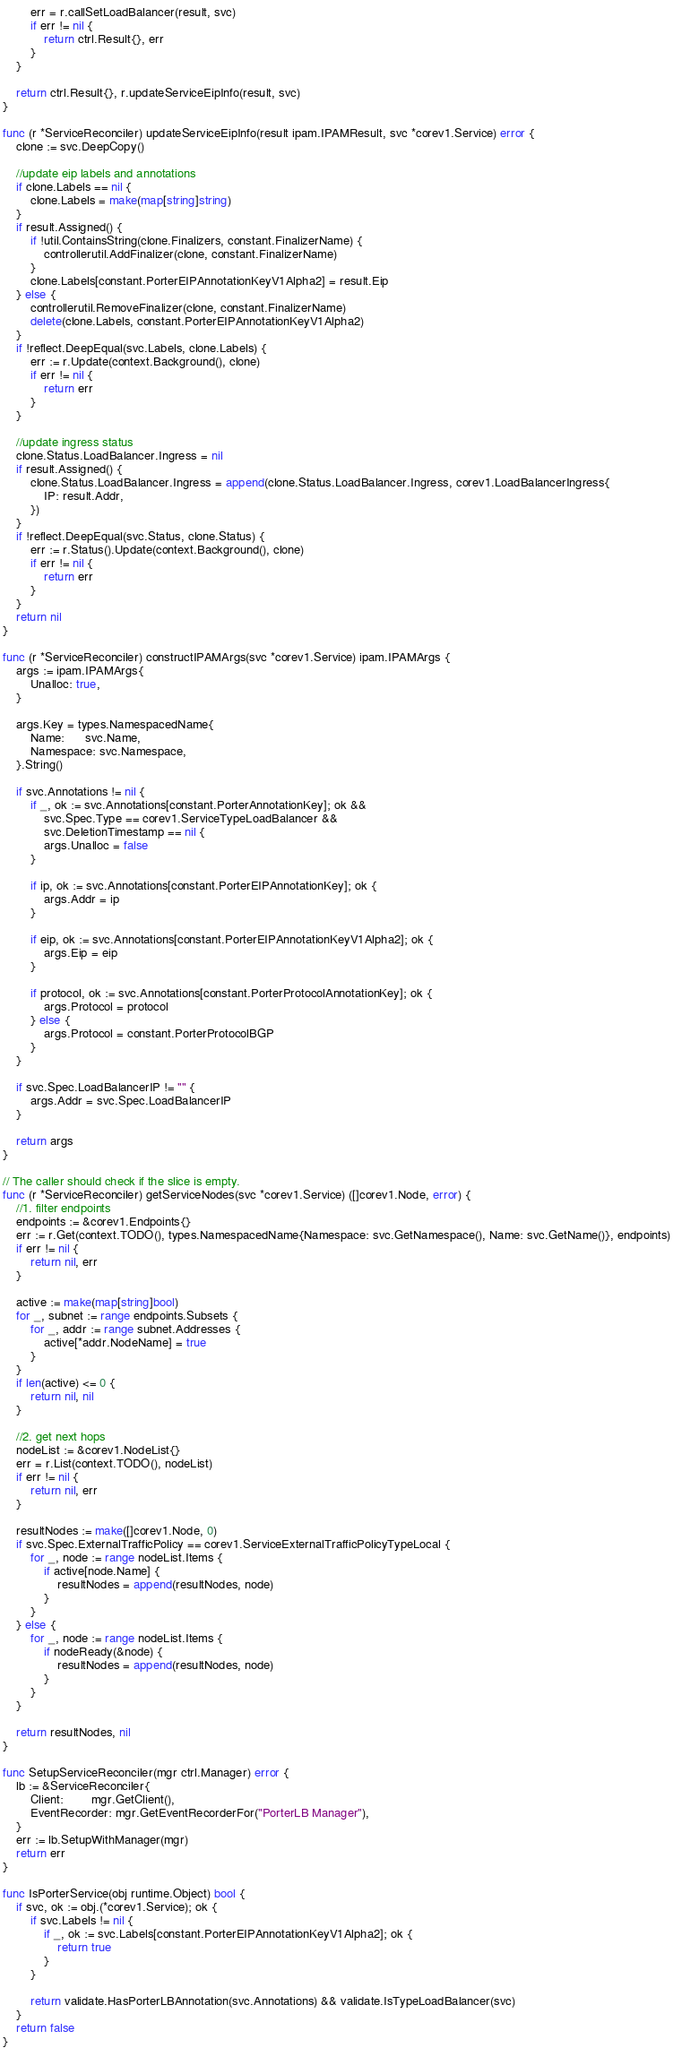<code> <loc_0><loc_0><loc_500><loc_500><_Go_>
		err = r.callSetLoadBalancer(result, svc)
		if err != nil {
			return ctrl.Result{}, err
		}
	}

	return ctrl.Result{}, r.updateServiceEipInfo(result, svc)
}

func (r *ServiceReconciler) updateServiceEipInfo(result ipam.IPAMResult, svc *corev1.Service) error {
	clone := svc.DeepCopy()

	//update eip labels and annotations
	if clone.Labels == nil {
		clone.Labels = make(map[string]string)
	}
	if result.Assigned() {
		if !util.ContainsString(clone.Finalizers, constant.FinalizerName) {
			controllerutil.AddFinalizer(clone, constant.FinalizerName)
		}
		clone.Labels[constant.PorterEIPAnnotationKeyV1Alpha2] = result.Eip
	} else {
		controllerutil.RemoveFinalizer(clone, constant.FinalizerName)
		delete(clone.Labels, constant.PorterEIPAnnotationKeyV1Alpha2)
	}
	if !reflect.DeepEqual(svc.Labels, clone.Labels) {
		err := r.Update(context.Background(), clone)
		if err != nil {
			return err
		}
	}

	//update ingress status
	clone.Status.LoadBalancer.Ingress = nil
	if result.Assigned() {
		clone.Status.LoadBalancer.Ingress = append(clone.Status.LoadBalancer.Ingress, corev1.LoadBalancerIngress{
			IP: result.Addr,
		})
	}
	if !reflect.DeepEqual(svc.Status, clone.Status) {
		err := r.Status().Update(context.Background(), clone)
		if err != nil {
			return err
		}
	}
	return nil
}

func (r *ServiceReconciler) constructIPAMArgs(svc *corev1.Service) ipam.IPAMArgs {
	args := ipam.IPAMArgs{
		Unalloc: true,
	}

	args.Key = types.NamespacedName{
		Name:      svc.Name,
		Namespace: svc.Namespace,
	}.String()

	if svc.Annotations != nil {
		if _, ok := svc.Annotations[constant.PorterAnnotationKey]; ok &&
			svc.Spec.Type == corev1.ServiceTypeLoadBalancer &&
			svc.DeletionTimestamp == nil {
			args.Unalloc = false
		}

		if ip, ok := svc.Annotations[constant.PorterEIPAnnotationKey]; ok {
			args.Addr = ip
		}

		if eip, ok := svc.Annotations[constant.PorterEIPAnnotationKeyV1Alpha2]; ok {
			args.Eip = eip
		}

		if protocol, ok := svc.Annotations[constant.PorterProtocolAnnotationKey]; ok {
			args.Protocol = protocol
		} else {
			args.Protocol = constant.PorterProtocolBGP
		}
	}

	if svc.Spec.LoadBalancerIP != "" {
		args.Addr = svc.Spec.LoadBalancerIP
	}

	return args
}

// The caller should check if the slice is empty.
func (r *ServiceReconciler) getServiceNodes(svc *corev1.Service) ([]corev1.Node, error) {
	//1. filter endpoints
	endpoints := &corev1.Endpoints{}
	err := r.Get(context.TODO(), types.NamespacedName{Namespace: svc.GetNamespace(), Name: svc.GetName()}, endpoints)
	if err != nil {
		return nil, err
	}

	active := make(map[string]bool)
	for _, subnet := range endpoints.Subsets {
		for _, addr := range subnet.Addresses {
			active[*addr.NodeName] = true
		}
	}
	if len(active) <= 0 {
		return nil, nil
	}

	//2. get next hops
	nodeList := &corev1.NodeList{}
	err = r.List(context.TODO(), nodeList)
	if err != nil {
		return nil, err
	}

	resultNodes := make([]corev1.Node, 0)
	if svc.Spec.ExternalTrafficPolicy == corev1.ServiceExternalTrafficPolicyTypeLocal {
		for _, node := range nodeList.Items {
			if active[node.Name] {
				resultNodes = append(resultNodes, node)
			}
		}
	} else {
		for _, node := range nodeList.Items {
			if nodeReady(&node) {
				resultNodes = append(resultNodes, node)
			}
		}
	}

	return resultNodes, nil
}

func SetupServiceReconciler(mgr ctrl.Manager) error {
	lb := &ServiceReconciler{
		Client:        mgr.GetClient(),
		EventRecorder: mgr.GetEventRecorderFor("PorterLB Manager"),
	}
	err := lb.SetupWithManager(mgr)
	return err
}

func IsPorterService(obj runtime.Object) bool {
	if svc, ok := obj.(*corev1.Service); ok {
		if svc.Labels != nil {
			if _, ok := svc.Labels[constant.PorterEIPAnnotationKeyV1Alpha2]; ok {
				return true
			}
		}

		return validate.HasPorterLBAnnotation(svc.Annotations) && validate.IsTypeLoadBalancer(svc)
	}
	return false
}
</code> 